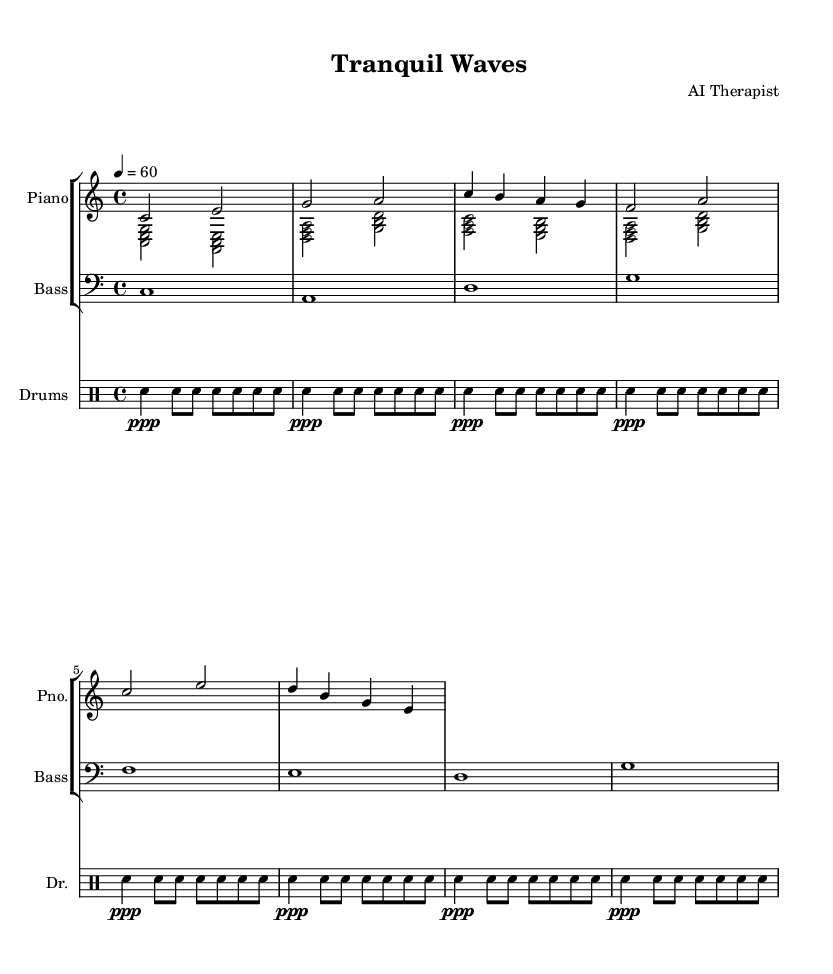What is the key signature of this music? The key signature is indicated at the beginning of the score, showing no sharps or flats, which corresponds to the C major scale.
Answer: C major What is the time signature of this music? The time signature is found at the beginning of the score as well; it indicates four beats per measure, as shown by the 4/4 notation.
Answer: 4/4 What is the tempo marking of this piece? The tempo is indicated later in the score, stating a quarter note equals 60 beats per minute, which indicates a slow and relaxing pace.
Answer: 60 How many measures are in the piano right hand part? By counting the individual segments separated by vertical bar lines, we find that there are a total of 8 measures in the right hand part.
Answer: 8 How does the left hand interact with the right hand? The left hand plays chords that complement the melody played by the right hand, contributing to a harmonious and soothing texture typical of jazz music.
Answer: Chords What type of rhythm pattern is used in the drum part? The drum part features a repeating pattern of soft snare hits with eighth notes, creating a light and steady rhythm that enhances the relaxation aspect of the piece.
Answer: Soft snare What is the overall mood conveyed by this piece? The combination of a slow tempo, soothing melodies, and harmonious chords leads to a calming and tranquil mood, suitable for relaxation and stress relief.
Answer: Calming 